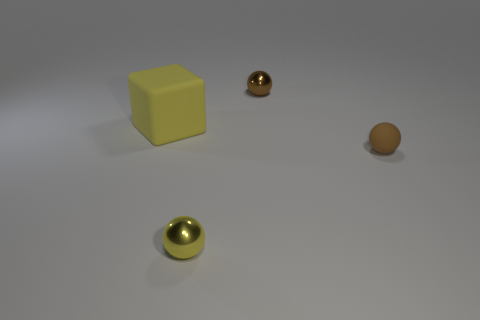Add 4 big yellow blocks. How many objects exist? 8 Subtract all spheres. How many objects are left? 1 Subtract all cyan rubber balls. Subtract all yellow shiny things. How many objects are left? 3 Add 3 big yellow rubber cubes. How many big yellow rubber cubes are left? 4 Add 2 brown matte objects. How many brown matte objects exist? 3 Subtract 0 blue cubes. How many objects are left? 4 